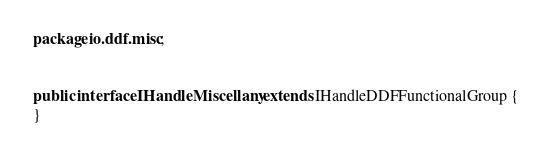Convert code to text. <code><loc_0><loc_0><loc_500><loc_500><_Java_>package io.ddf.misc;


public interface IHandleMiscellany extends IHandleDDFFunctionalGroup {
}
</code> 